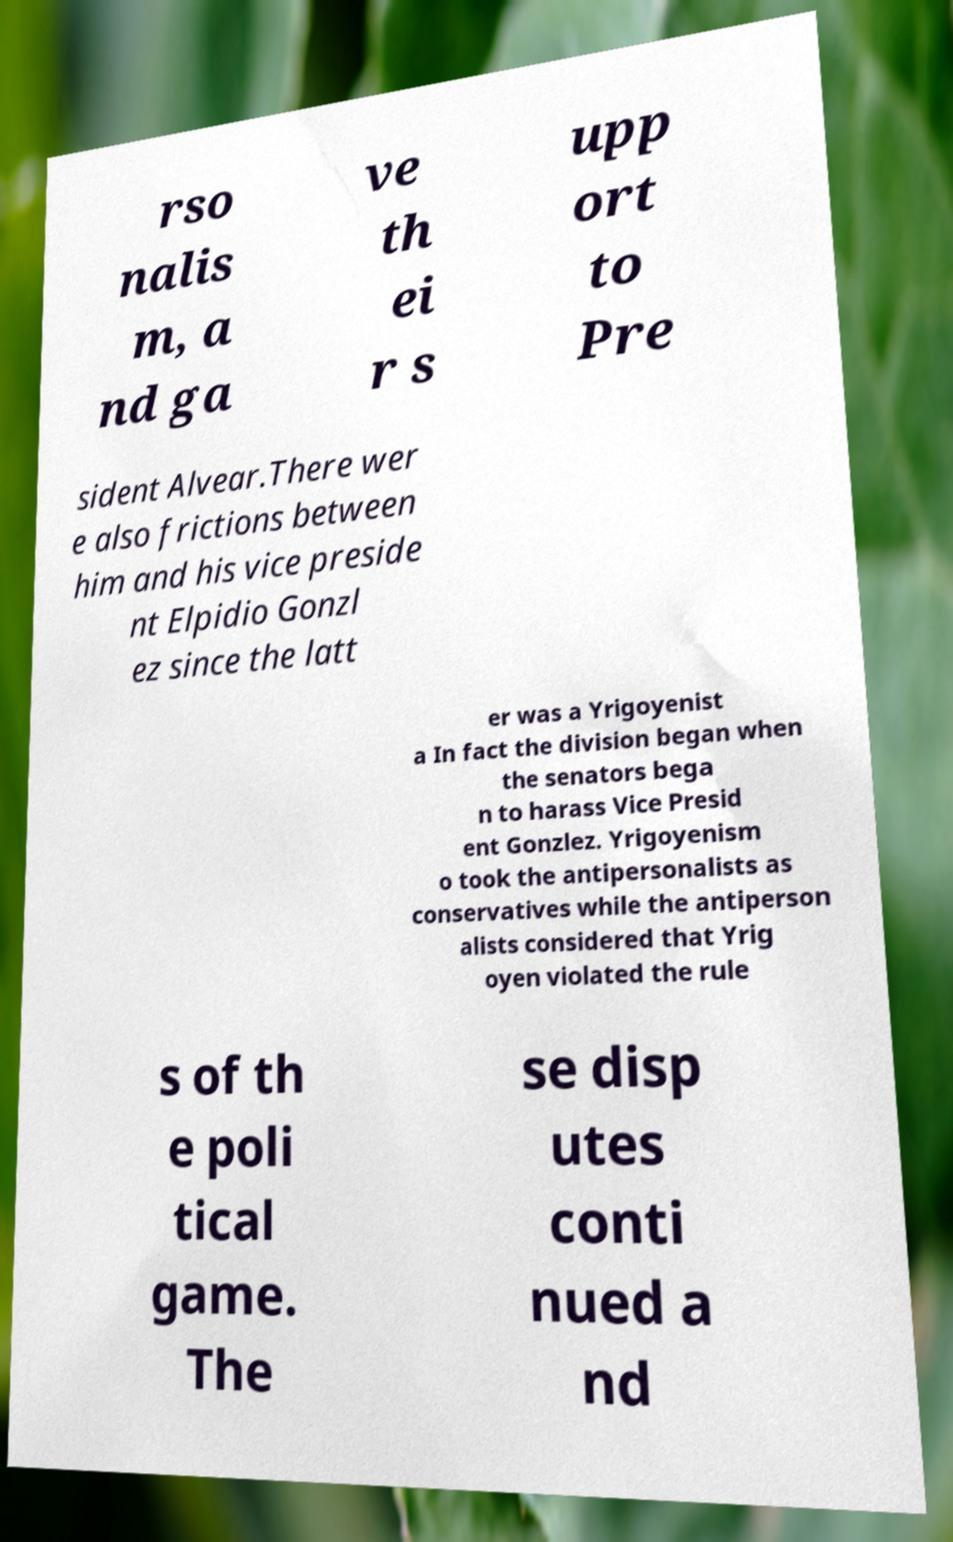Please read and relay the text visible in this image. What does it say? rso nalis m, a nd ga ve th ei r s upp ort to Pre sident Alvear.There wer e also frictions between him and his vice preside nt Elpidio Gonzl ez since the latt er was a Yrigoyenist a In fact the division began when the senators bega n to harass Vice Presid ent Gonzlez. Yrigoyenism o took the antipersonalists as conservatives while the antiperson alists considered that Yrig oyen violated the rule s of th e poli tical game. The se disp utes conti nued a nd 